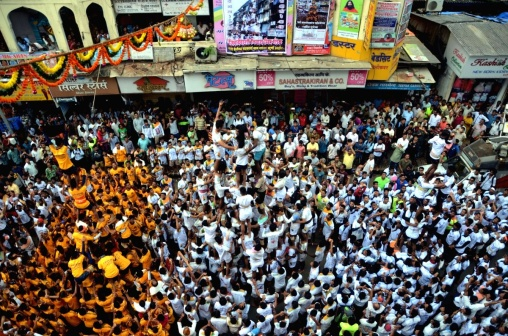What can you infer about the location of this event? This event takes place in an urban street setting, as evidenced by the storefronts and commercial banners in the background, which bear non-Latin script indicating that the location is likely in a region where such script is predominant. The architecture of the buildings and the visible banners suggest a South Asian country, which, combined with the attire of the crowd, might point to a specific cultural context. 